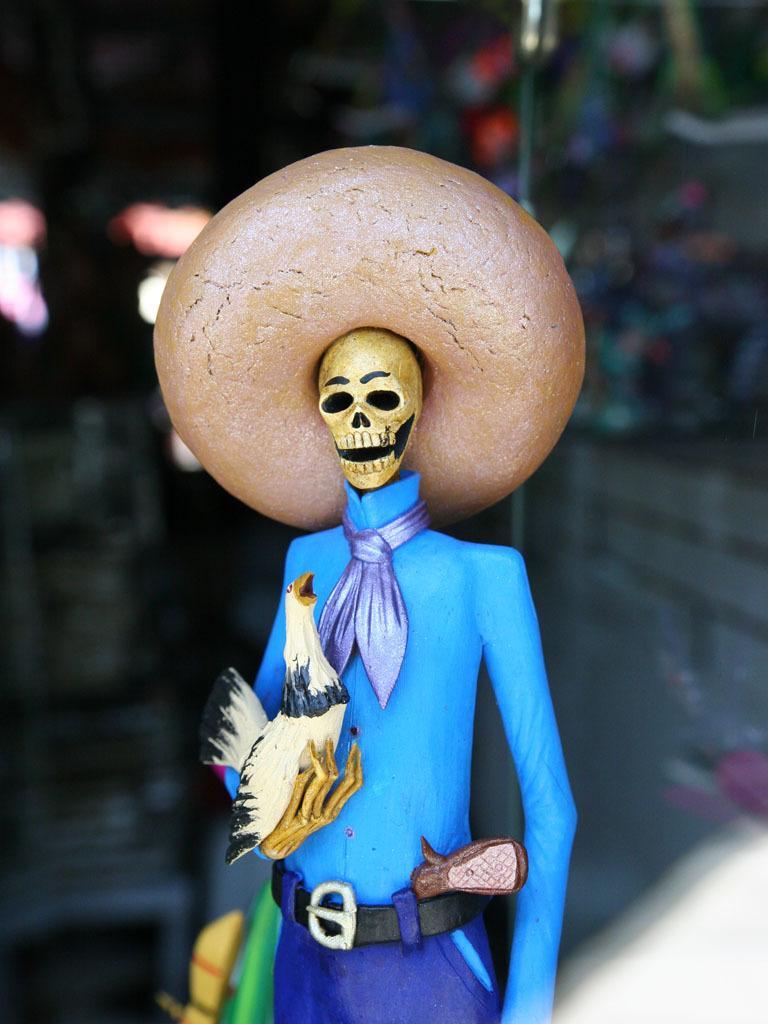Please provide a concise description of this image. In the middle of the image we can see toy. In the background it is blur. 